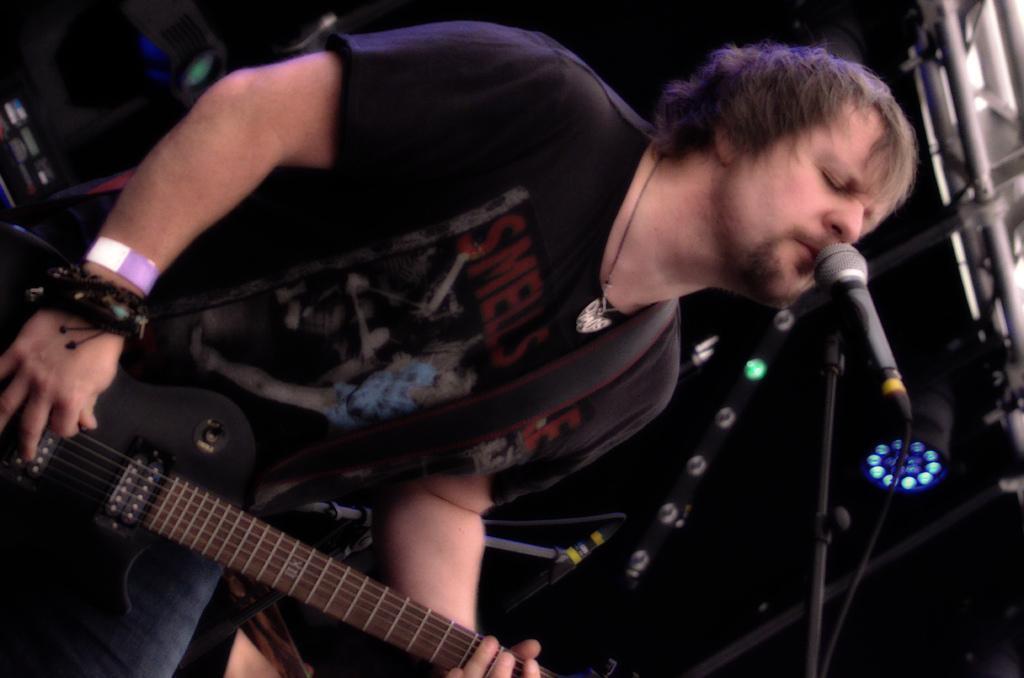Describe this image in one or two sentences. A man is singing with a mic in front of him while playing a guitar. 